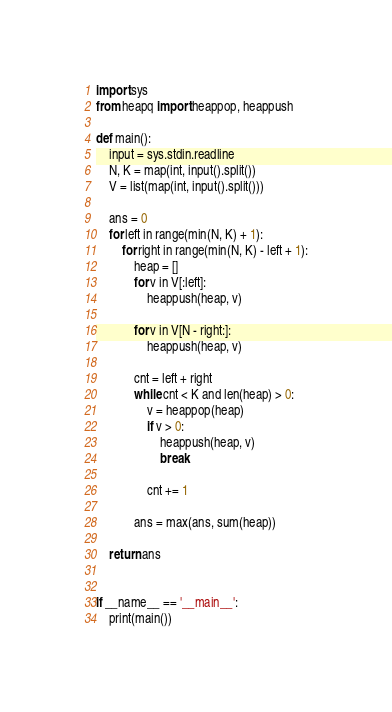<code> <loc_0><loc_0><loc_500><loc_500><_Python_>import sys
from heapq import heappop, heappush

def main():
    input = sys.stdin.readline
    N, K = map(int, input().split())
    V = list(map(int, input().split()))

    ans = 0
    for left in range(min(N, K) + 1):
        for right in range(min(N, K) - left + 1):
            heap = []
            for v in V[:left]:
                heappush(heap, v)

            for v in V[N - right:]:
                heappush(heap, v)

            cnt = left + right
            while cnt < K and len(heap) > 0:
                v = heappop(heap)
                if v > 0:
                    heappush(heap, v)
                    break

                cnt += 1

            ans = max(ans, sum(heap))

    return ans


if __name__ == '__main__':
    print(main())
</code> 